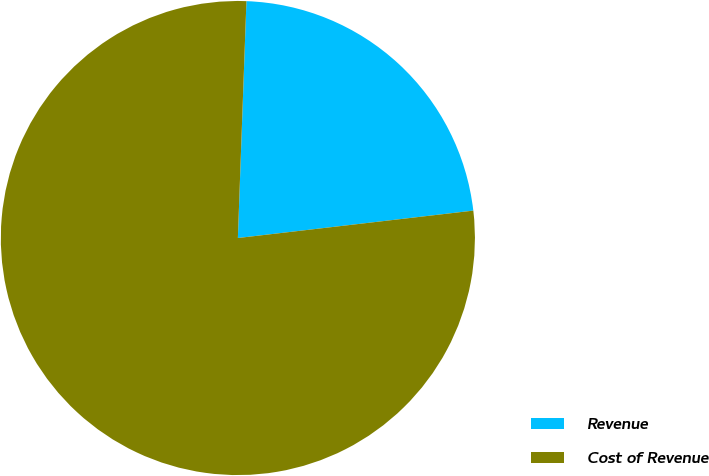Convert chart to OTSL. <chart><loc_0><loc_0><loc_500><loc_500><pie_chart><fcel>Revenue<fcel>Cost of Revenue<nl><fcel>22.58%<fcel>77.42%<nl></chart> 